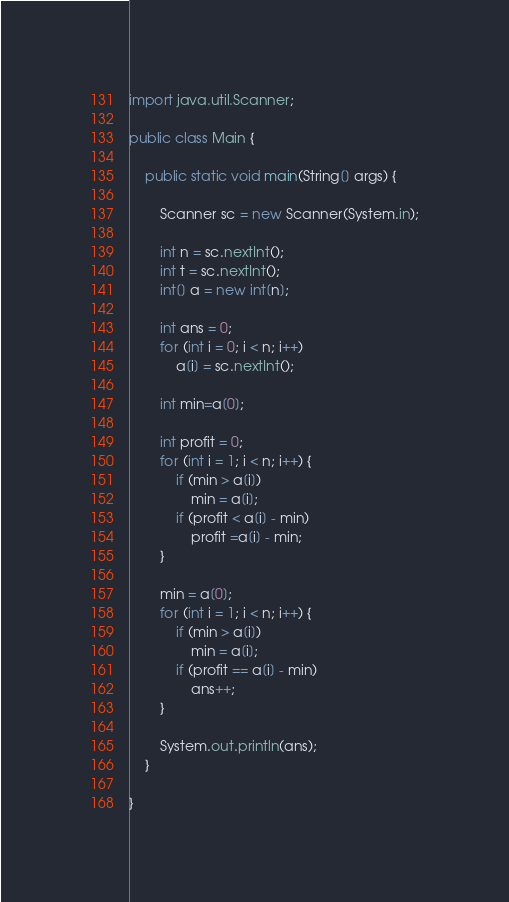Convert code to text. <code><loc_0><loc_0><loc_500><loc_500><_Java_>import java.util.Scanner;

public class Main {

	public static void main(String[] args) {

		Scanner sc = new Scanner(System.in);

		int n = sc.nextInt();
		int t = sc.nextInt();
		int[] a = new int[n];

		int ans = 0;
		for (int i = 0; i < n; i++)
			a[i] = sc.nextInt();
		
		int min=a[0];
		
		int profit = 0;
		for (int i = 1; i < n; i++) {
			if (min > a[i])
				min = a[i];
			if (profit < a[i] - min)
				profit =a[i] - min;
		}

		min = a[0];
		for (int i = 1; i < n; i++) {
			if (min > a[i])
				min = a[i];
			if (profit == a[i] - min)
				ans++;
		}

		System.out.println(ans);
	}

}
</code> 